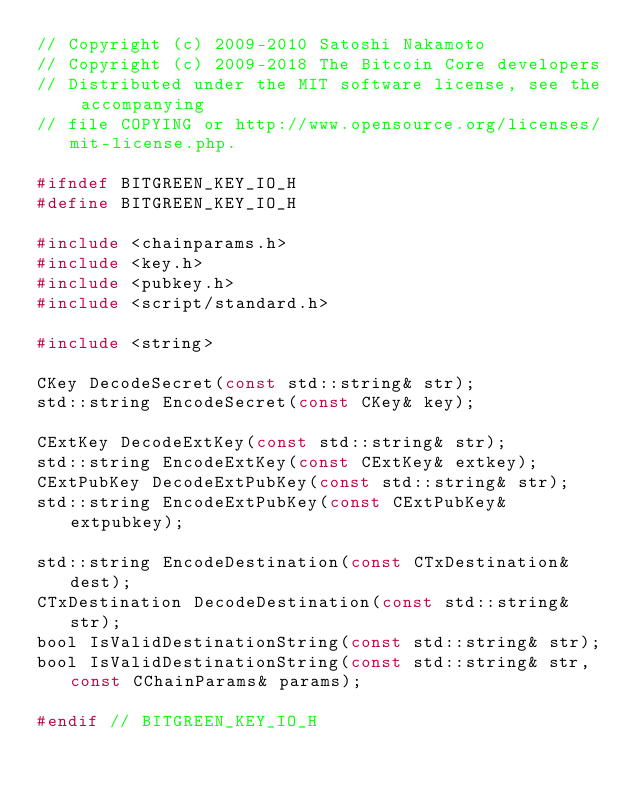Convert code to text. <code><loc_0><loc_0><loc_500><loc_500><_C_>// Copyright (c) 2009-2010 Satoshi Nakamoto
// Copyright (c) 2009-2018 The Bitcoin Core developers
// Distributed under the MIT software license, see the accompanying
// file COPYING or http://www.opensource.org/licenses/mit-license.php.

#ifndef BITGREEN_KEY_IO_H
#define BITGREEN_KEY_IO_H

#include <chainparams.h>
#include <key.h>
#include <pubkey.h>
#include <script/standard.h>

#include <string>

CKey DecodeSecret(const std::string& str);
std::string EncodeSecret(const CKey& key);

CExtKey DecodeExtKey(const std::string& str);
std::string EncodeExtKey(const CExtKey& extkey);
CExtPubKey DecodeExtPubKey(const std::string& str);
std::string EncodeExtPubKey(const CExtPubKey& extpubkey);

std::string EncodeDestination(const CTxDestination& dest);
CTxDestination DecodeDestination(const std::string& str);
bool IsValidDestinationString(const std::string& str);
bool IsValidDestinationString(const std::string& str, const CChainParams& params);

#endif // BITGREEN_KEY_IO_H
</code> 